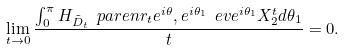<formula> <loc_0><loc_0><loc_500><loc_500>\lim _ { t \rightarrow 0 } \frac { \int _ { 0 } ^ { \pi } H _ { \tilde { D } _ { t } } \ p a r e n { r _ { t } e ^ { i \theta } , e ^ { i \theta _ { 1 } } } \ e v { e ^ { i \theta _ { 1 } } } { X _ { 2 } ^ { t } } d \theta _ { 1 } } { t } = 0 .</formula> 